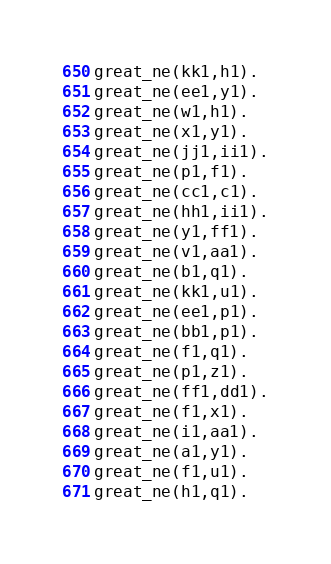<code> <loc_0><loc_0><loc_500><loc_500><_FORTRAN_>great_ne(kk1,h1).
great_ne(ee1,y1).
great_ne(w1,h1).
great_ne(x1,y1).
great_ne(jj1,ii1).
great_ne(p1,f1).
great_ne(cc1,c1).
great_ne(hh1,ii1).
great_ne(y1,ff1).
great_ne(v1,aa1).
great_ne(b1,q1).
great_ne(kk1,u1).
great_ne(ee1,p1).
great_ne(bb1,p1).
great_ne(f1,q1).
great_ne(p1,z1).
great_ne(ff1,dd1).
great_ne(f1,x1).
great_ne(i1,aa1).
great_ne(a1,y1).
great_ne(f1,u1).
great_ne(h1,q1).
</code> 